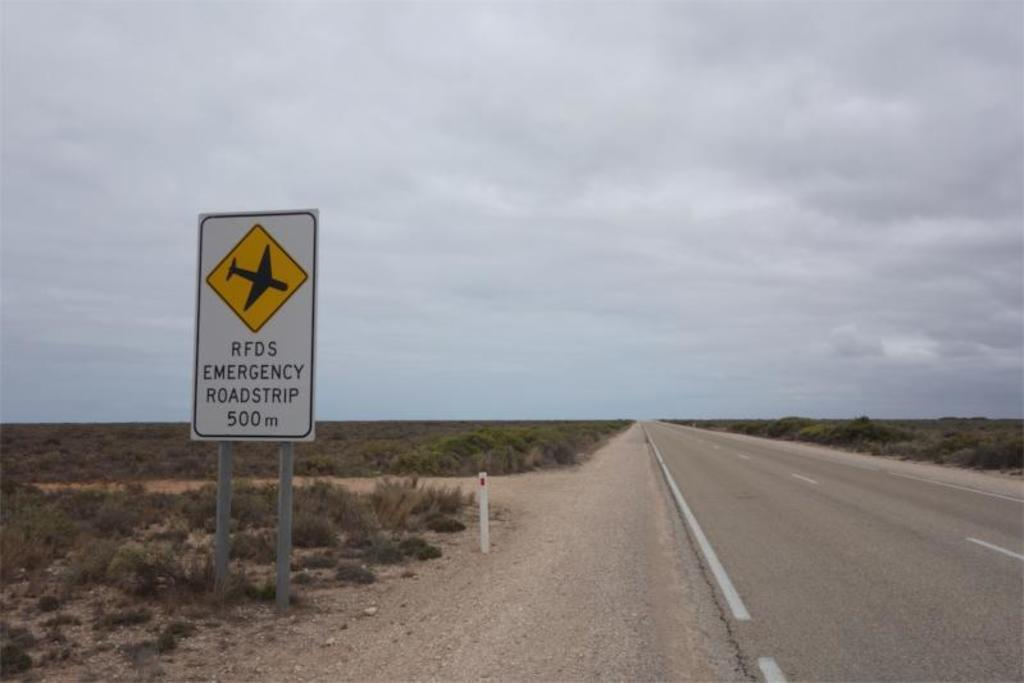<image>
Present a compact description of the photo's key features. A sign next to an empty road explaining that it can be used as an Emergency Roadstrip for airplanes. 